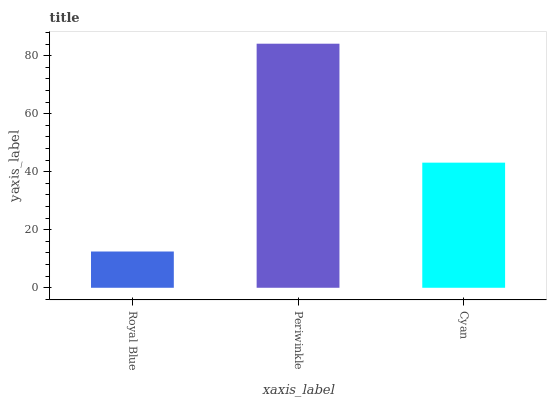Is Royal Blue the minimum?
Answer yes or no. Yes. Is Periwinkle the maximum?
Answer yes or no. Yes. Is Cyan the minimum?
Answer yes or no. No. Is Cyan the maximum?
Answer yes or no. No. Is Periwinkle greater than Cyan?
Answer yes or no. Yes. Is Cyan less than Periwinkle?
Answer yes or no. Yes. Is Cyan greater than Periwinkle?
Answer yes or no. No. Is Periwinkle less than Cyan?
Answer yes or no. No. Is Cyan the high median?
Answer yes or no. Yes. Is Cyan the low median?
Answer yes or no. Yes. Is Royal Blue the high median?
Answer yes or no. No. Is Periwinkle the low median?
Answer yes or no. No. 